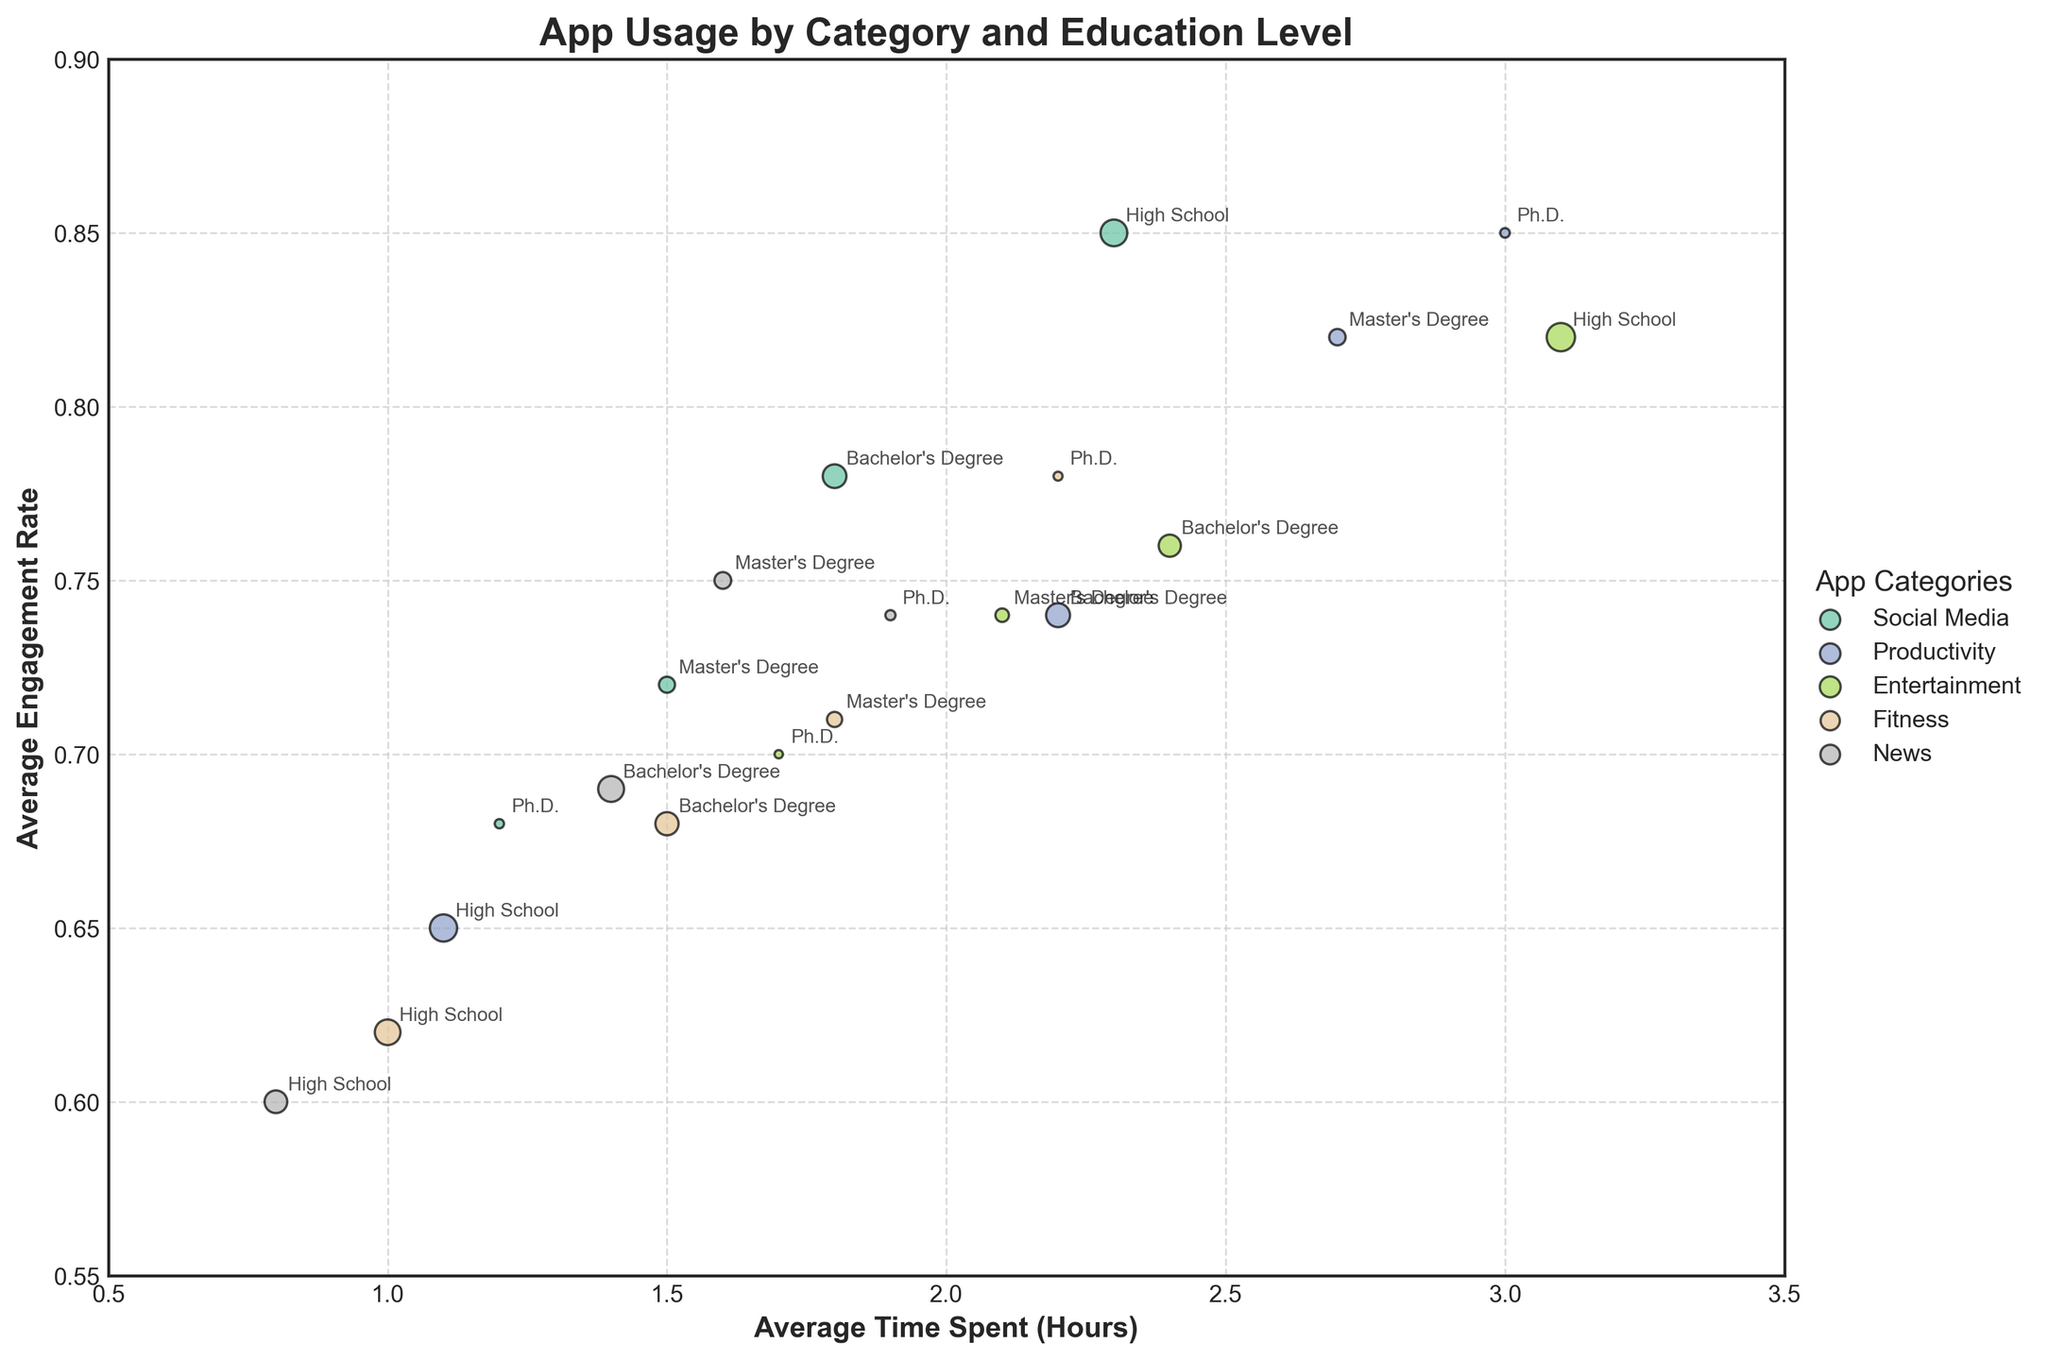what is the title of the plot? The title of the plot is "App Usage by Category and Education Level", which is prominently displayed at the top of the figure
Answer: App Usage by Category and Education Level Which category has the largest bubble size in the subplot? To determine the largest bubble size, observe the scatter plots and identify the bubble(s) that appear largest in size. The largest bubble corresponds to Entertainment for High School, indicating this category has the maximum number of users at this education level.
Answer: Entertainment for High School Which education level spends the most time on Productivity apps? To find this, look at the x-axis values (Average Time Spent in Hours) for each education level within the Productivity category. The Ph.D. level spends the most time on productivity apps, with an average of 3.0 hours.
Answer: Ph.D Among all education levels, which category has the highest Average Engagement Rate? Examine the y-axis values (Average Engagement Rate) for each bubble within each category. The highest engagement rate is 0.85, visible in the Social Media category for High School, and Productivity category for Ph.D.
Answer: Social Media for High School and Productivity for Ph.D How does engagement rate compare between High School and Ph.D. levels for Entertainment apps? Check the y-axis values for Entertainment category corresponding to High School and Ph.D. levels. High School has an engagement rate of 0.82, whereas Ph.D. has an engagement rate of 0.7.
Answer: Higher for High School What is the total number of users for apps categorized under News? Look at the bubble sizes for each education level within the News category. Sum the user counts (size values) for High School (900), Bachelor's Degree (1170), Master's Degree (490), and Ph.D. (180). Total is 900 + 1170 + 490 + 180 = 2740.
Answer: 2740 Which education level has the highest average engagement rate for Fitness apps? Identify the bubbles under the Fitness category and compare their y-axis values. The highest engagement rate is 0.78, belonging to the Ph.D. level.
Answer: Ph.D What can be said about the relationship between Education Level and Time Spent on Social Media? Examine the x-axis values for Social Media across different education levels. As education level increases from High School to Ph.D., the average time spent on social media decreases, showing an inverse relationship.
Answer: Inversely related Based on the plot, which category is most actively used by users with a Bachelor’s Degree? Check the bubble sizes for Bachelor's Degree across all categories. The largest bubble size is for News, with 1170 users.
Answer: News Which category has lower engagement rates at higher education levels? Compare engagement rates across categories for higher education levels (Master's Degree and Ph.D.). Both Social Media and Entertainment categories show significantly lower engagement rates as education level increases.
Answer: Social Media and Entertainment 